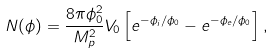<formula> <loc_0><loc_0><loc_500><loc_500>N ( \phi ) = \frac { 8 \pi \phi _ { 0 } ^ { 2 } } { M _ { p } ^ { 2 } } V _ { 0 } \left [ e ^ { - \phi _ { i } / \phi _ { 0 } } - e ^ { - \phi _ { e } / \phi _ { 0 } } \right ] ,</formula> 